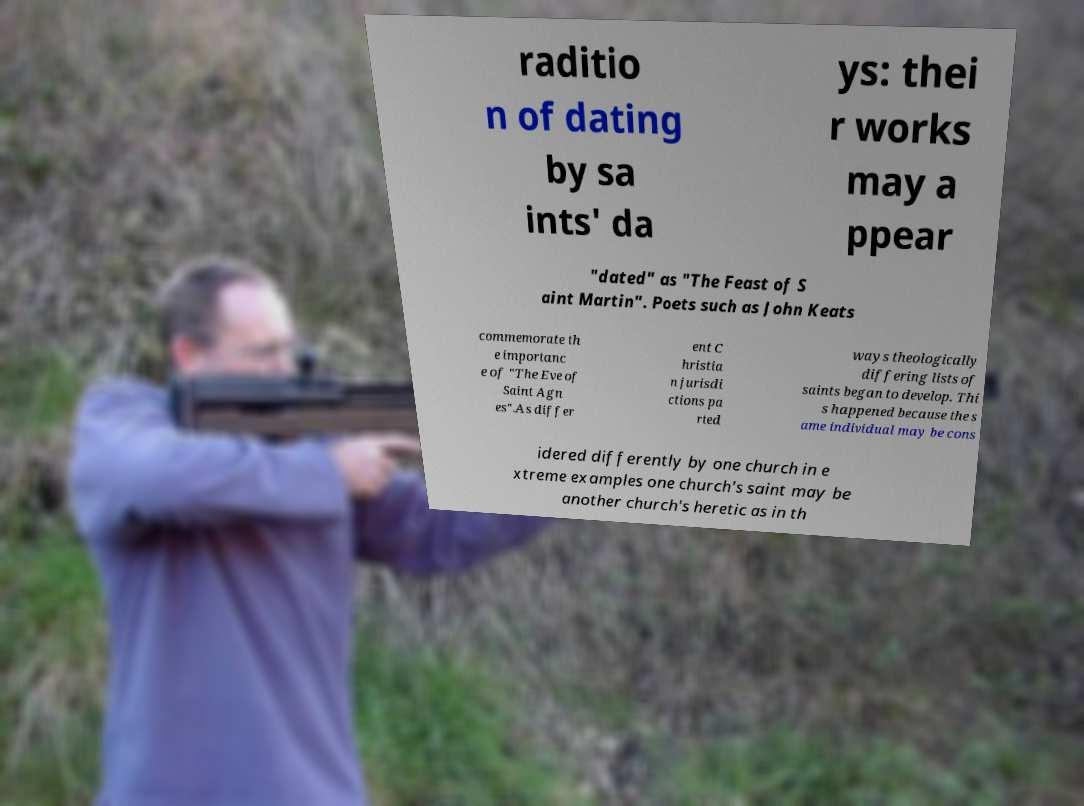What messages or text are displayed in this image? I need them in a readable, typed format. raditio n of dating by sa ints' da ys: thei r works may a ppear "dated" as "The Feast of S aint Martin". Poets such as John Keats commemorate th e importanc e of "The Eve of Saint Agn es".As differ ent C hristia n jurisdi ctions pa rted ways theologically differing lists of saints began to develop. Thi s happened because the s ame individual may be cons idered differently by one church in e xtreme examples one church's saint may be another church's heretic as in th 